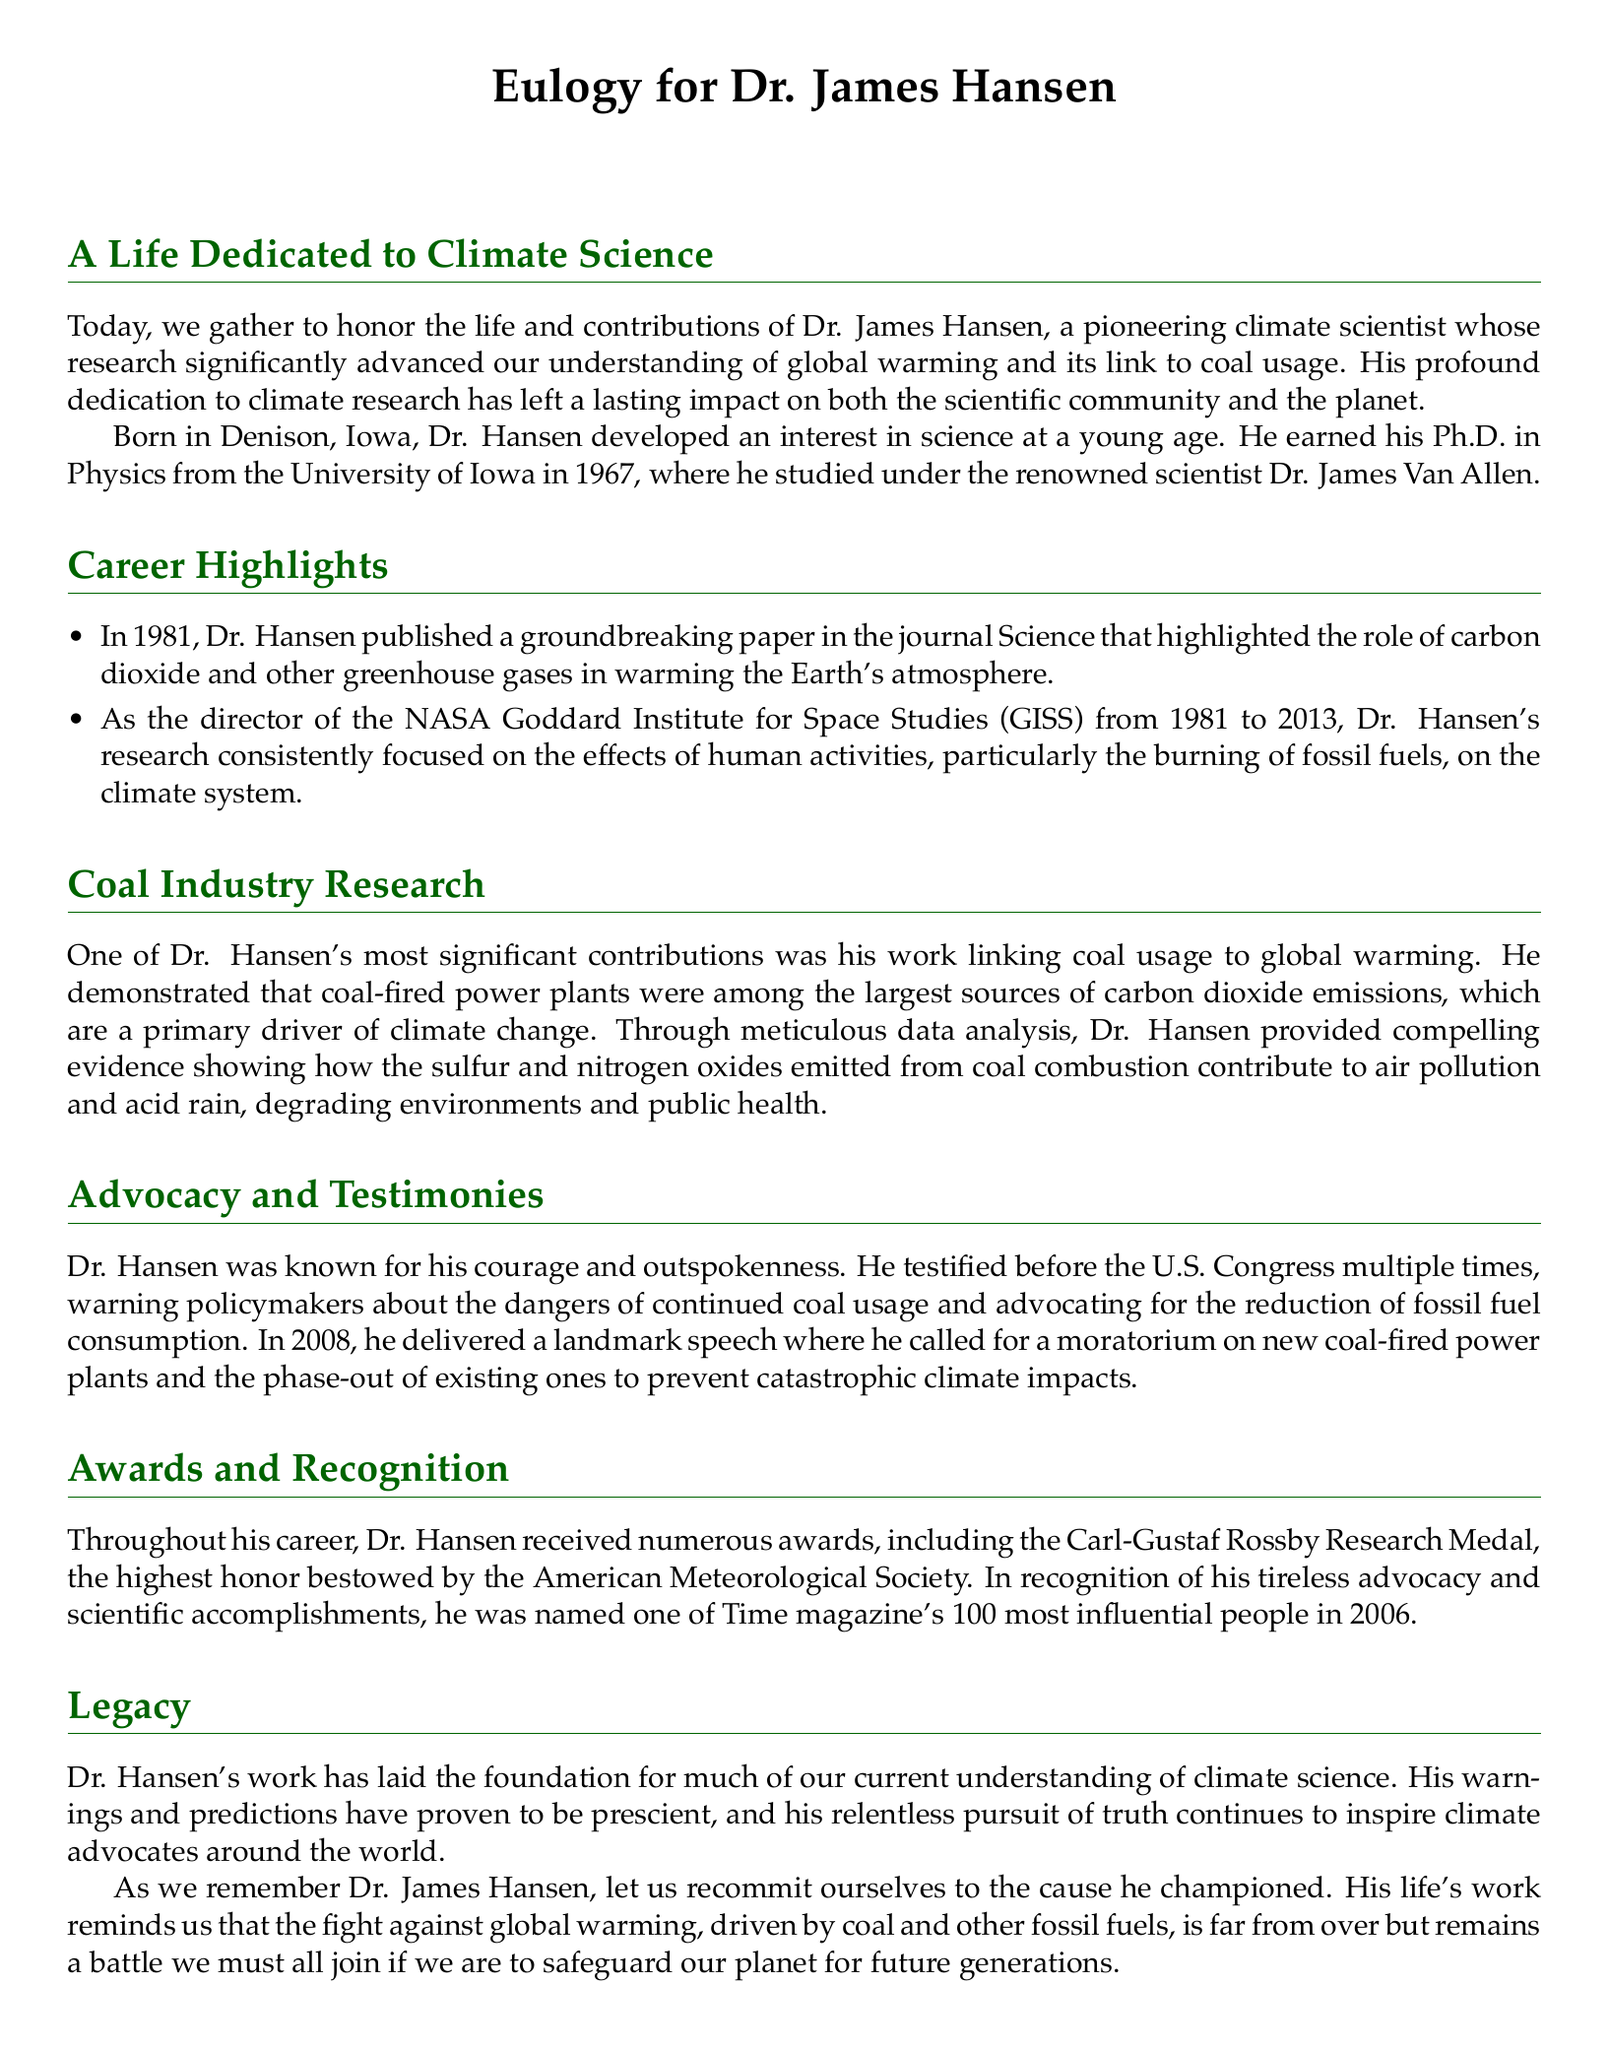What was Dr. Hansen's birthplace? The document states that Dr. Hansen was born in Denison, Iowa.
Answer: Denison, Iowa In which year did Dr. Hansen earn his Ph.D.? The document mentions that Dr. Hansen earned his Ph.D. in 1967.
Answer: 1967 How long did Dr. Hansen serve as the director of NASA GISS? The document indicates that he served from 1981 to 2013, which is a total of 32 years.
Answer: 32 years What was one of Dr. Hansen's significant contributions? The document highlights his work linking coal usage to global warming as a significant contribution.
Answer: Linking coal usage to global warming What award did Dr. Hansen receive from the American Meteorological Society? According to the document, he received the Carl-Gustaf Rossby Research Medal.
Answer: Carl-Gustaf Rossby Research Medal What did Dr. Hansen advocate for in his 2008 speech? The document notes that he called for a moratorium on new coal-fired power plants.
Answer: Moratorium on new coal-fired power plants What is the main theme of Dr. Hansen's legacy? The document states that his work laid the foundation for our understanding of climate science.
Answer: Foundation for our understanding of climate science What type of document is this? The nature of the document is a eulogy focusing on a scientist's contributions.
Answer: Eulogy How many times did Dr. Hansen testify before the U.S. Congress? The document mentions that he testified multiple times, indicating at least two instances.
Answer: Multiple times What does the eulogy remind us regarding climate change? The document emphasizes the need to continue the fight against global warming driven by fossil fuels.
Answer: Continue the fight against global warming 